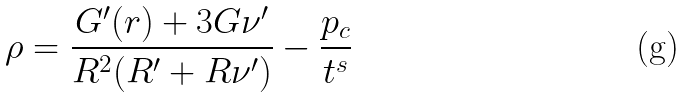<formula> <loc_0><loc_0><loc_500><loc_500>\rho = \frac { G ^ { \prime } ( r ) + 3 G \nu ^ { \prime } } { R ^ { 2 } ( R ^ { \prime } + R \nu ^ { \prime } ) } - \frac { p _ { c } } { t ^ { s } }</formula> 